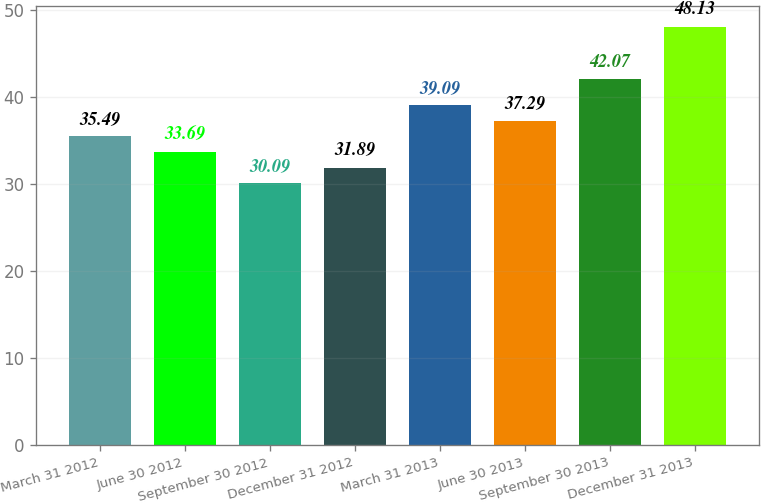Convert chart to OTSL. <chart><loc_0><loc_0><loc_500><loc_500><bar_chart><fcel>March 31 2012<fcel>June 30 2012<fcel>September 30 2012<fcel>December 31 2012<fcel>March 31 2013<fcel>June 30 2013<fcel>September 30 2013<fcel>December 31 2013<nl><fcel>35.49<fcel>33.69<fcel>30.09<fcel>31.89<fcel>39.09<fcel>37.29<fcel>42.07<fcel>48.13<nl></chart> 